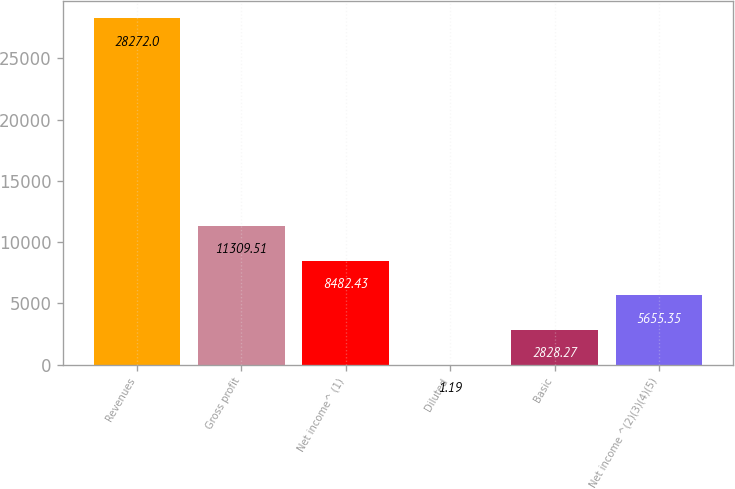Convert chart. <chart><loc_0><loc_0><loc_500><loc_500><bar_chart><fcel>Revenues<fcel>Gross profit<fcel>Net income^ (1)<fcel>Diluted<fcel>Basic<fcel>Net income ^(2)(3)(4)(5)<nl><fcel>28272<fcel>11309.5<fcel>8482.43<fcel>1.19<fcel>2828.27<fcel>5655.35<nl></chart> 